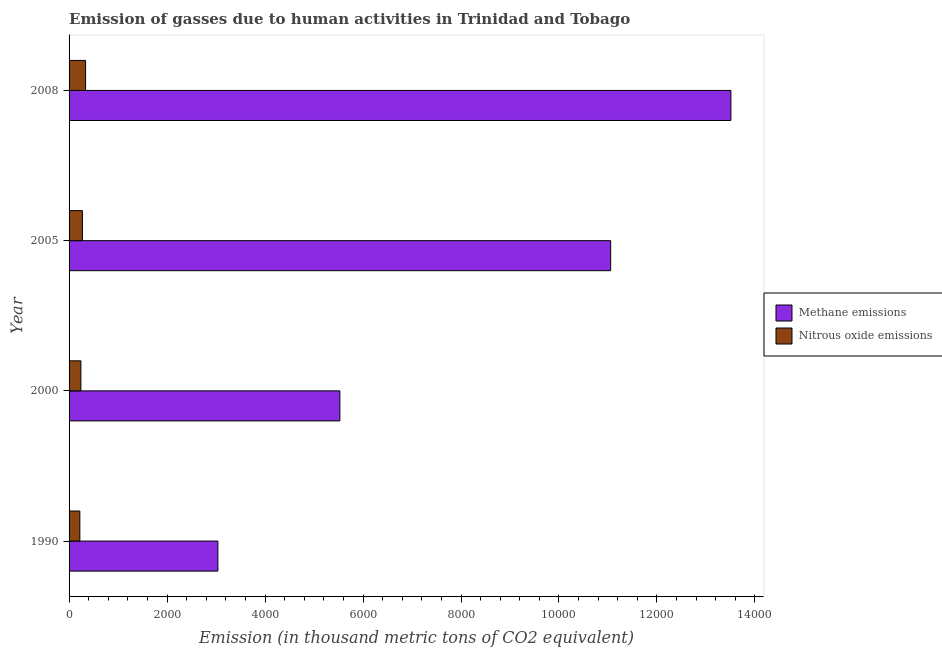How many different coloured bars are there?
Give a very brief answer. 2. Are the number of bars on each tick of the Y-axis equal?
Keep it short and to the point. Yes. How many bars are there on the 1st tick from the top?
Offer a terse response. 2. How many bars are there on the 3rd tick from the bottom?
Your answer should be very brief. 2. What is the label of the 2nd group of bars from the top?
Your response must be concise. 2005. What is the amount of nitrous oxide emissions in 2005?
Provide a short and direct response. 272.8. Across all years, what is the maximum amount of methane emissions?
Ensure brevity in your answer.  1.35e+04. Across all years, what is the minimum amount of methane emissions?
Your answer should be very brief. 3037.6. In which year was the amount of methane emissions minimum?
Your answer should be very brief. 1990. What is the total amount of nitrous oxide emissions in the graph?
Your answer should be compact. 1071. What is the difference between the amount of methane emissions in 1990 and that in 2000?
Give a very brief answer. -2489.9. What is the difference between the amount of methane emissions in 2000 and the amount of nitrous oxide emissions in 2008?
Your response must be concise. 5190.7. What is the average amount of methane emissions per year?
Your response must be concise. 8282.1. In the year 2000, what is the difference between the amount of nitrous oxide emissions and amount of methane emissions?
Offer a very short reply. -5286. What is the ratio of the amount of nitrous oxide emissions in 1990 to that in 2008?
Provide a short and direct response. 0.65. Is the amount of methane emissions in 1990 less than that in 2008?
Offer a very short reply. Yes. Is the difference between the amount of methane emissions in 2005 and 2008 greater than the difference between the amount of nitrous oxide emissions in 2005 and 2008?
Your answer should be compact. No. What is the difference between the highest and the second highest amount of methane emissions?
Offer a terse response. 2453.9. What is the difference between the highest and the lowest amount of methane emissions?
Give a very brief answer. 1.05e+04. In how many years, is the amount of nitrous oxide emissions greater than the average amount of nitrous oxide emissions taken over all years?
Your answer should be compact. 2. What does the 2nd bar from the top in 1990 represents?
Make the answer very short. Methane emissions. What does the 1st bar from the bottom in 2005 represents?
Your answer should be compact. Methane emissions. How are the legend labels stacked?
Make the answer very short. Vertical. What is the title of the graph?
Offer a terse response. Emission of gasses due to human activities in Trinidad and Tobago. Does "Transport services" appear as one of the legend labels in the graph?
Provide a short and direct response. No. What is the label or title of the X-axis?
Provide a succinct answer. Emission (in thousand metric tons of CO2 equivalent). What is the label or title of the Y-axis?
Provide a succinct answer. Year. What is the Emission (in thousand metric tons of CO2 equivalent) in Methane emissions in 1990?
Your answer should be very brief. 3037.6. What is the Emission (in thousand metric tons of CO2 equivalent) of Nitrous oxide emissions in 1990?
Your answer should be very brief. 219.9. What is the Emission (in thousand metric tons of CO2 equivalent) in Methane emissions in 2000?
Keep it short and to the point. 5527.5. What is the Emission (in thousand metric tons of CO2 equivalent) of Nitrous oxide emissions in 2000?
Ensure brevity in your answer.  241.5. What is the Emission (in thousand metric tons of CO2 equivalent) in Methane emissions in 2005?
Your answer should be compact. 1.11e+04. What is the Emission (in thousand metric tons of CO2 equivalent) of Nitrous oxide emissions in 2005?
Your response must be concise. 272.8. What is the Emission (in thousand metric tons of CO2 equivalent) in Methane emissions in 2008?
Offer a very short reply. 1.35e+04. What is the Emission (in thousand metric tons of CO2 equivalent) in Nitrous oxide emissions in 2008?
Give a very brief answer. 336.8. Across all years, what is the maximum Emission (in thousand metric tons of CO2 equivalent) of Methane emissions?
Offer a very short reply. 1.35e+04. Across all years, what is the maximum Emission (in thousand metric tons of CO2 equivalent) in Nitrous oxide emissions?
Your answer should be compact. 336.8. Across all years, what is the minimum Emission (in thousand metric tons of CO2 equivalent) in Methane emissions?
Make the answer very short. 3037.6. Across all years, what is the minimum Emission (in thousand metric tons of CO2 equivalent) of Nitrous oxide emissions?
Provide a short and direct response. 219.9. What is the total Emission (in thousand metric tons of CO2 equivalent) in Methane emissions in the graph?
Keep it short and to the point. 3.31e+04. What is the total Emission (in thousand metric tons of CO2 equivalent) of Nitrous oxide emissions in the graph?
Give a very brief answer. 1071. What is the difference between the Emission (in thousand metric tons of CO2 equivalent) in Methane emissions in 1990 and that in 2000?
Ensure brevity in your answer.  -2489.9. What is the difference between the Emission (in thousand metric tons of CO2 equivalent) in Nitrous oxide emissions in 1990 and that in 2000?
Provide a succinct answer. -21.6. What is the difference between the Emission (in thousand metric tons of CO2 equivalent) of Methane emissions in 1990 and that in 2005?
Provide a succinct answer. -8017.1. What is the difference between the Emission (in thousand metric tons of CO2 equivalent) in Nitrous oxide emissions in 1990 and that in 2005?
Offer a terse response. -52.9. What is the difference between the Emission (in thousand metric tons of CO2 equivalent) of Methane emissions in 1990 and that in 2008?
Your response must be concise. -1.05e+04. What is the difference between the Emission (in thousand metric tons of CO2 equivalent) of Nitrous oxide emissions in 1990 and that in 2008?
Your answer should be compact. -116.9. What is the difference between the Emission (in thousand metric tons of CO2 equivalent) in Methane emissions in 2000 and that in 2005?
Your answer should be very brief. -5527.2. What is the difference between the Emission (in thousand metric tons of CO2 equivalent) in Nitrous oxide emissions in 2000 and that in 2005?
Your answer should be compact. -31.3. What is the difference between the Emission (in thousand metric tons of CO2 equivalent) of Methane emissions in 2000 and that in 2008?
Your answer should be compact. -7981.1. What is the difference between the Emission (in thousand metric tons of CO2 equivalent) in Nitrous oxide emissions in 2000 and that in 2008?
Offer a terse response. -95.3. What is the difference between the Emission (in thousand metric tons of CO2 equivalent) in Methane emissions in 2005 and that in 2008?
Give a very brief answer. -2453.9. What is the difference between the Emission (in thousand metric tons of CO2 equivalent) in Nitrous oxide emissions in 2005 and that in 2008?
Provide a short and direct response. -64. What is the difference between the Emission (in thousand metric tons of CO2 equivalent) in Methane emissions in 1990 and the Emission (in thousand metric tons of CO2 equivalent) in Nitrous oxide emissions in 2000?
Offer a very short reply. 2796.1. What is the difference between the Emission (in thousand metric tons of CO2 equivalent) of Methane emissions in 1990 and the Emission (in thousand metric tons of CO2 equivalent) of Nitrous oxide emissions in 2005?
Your answer should be very brief. 2764.8. What is the difference between the Emission (in thousand metric tons of CO2 equivalent) in Methane emissions in 1990 and the Emission (in thousand metric tons of CO2 equivalent) in Nitrous oxide emissions in 2008?
Your answer should be compact. 2700.8. What is the difference between the Emission (in thousand metric tons of CO2 equivalent) in Methane emissions in 2000 and the Emission (in thousand metric tons of CO2 equivalent) in Nitrous oxide emissions in 2005?
Offer a terse response. 5254.7. What is the difference between the Emission (in thousand metric tons of CO2 equivalent) of Methane emissions in 2000 and the Emission (in thousand metric tons of CO2 equivalent) of Nitrous oxide emissions in 2008?
Your answer should be compact. 5190.7. What is the difference between the Emission (in thousand metric tons of CO2 equivalent) of Methane emissions in 2005 and the Emission (in thousand metric tons of CO2 equivalent) of Nitrous oxide emissions in 2008?
Give a very brief answer. 1.07e+04. What is the average Emission (in thousand metric tons of CO2 equivalent) of Methane emissions per year?
Your answer should be very brief. 8282.1. What is the average Emission (in thousand metric tons of CO2 equivalent) in Nitrous oxide emissions per year?
Ensure brevity in your answer.  267.75. In the year 1990, what is the difference between the Emission (in thousand metric tons of CO2 equivalent) of Methane emissions and Emission (in thousand metric tons of CO2 equivalent) of Nitrous oxide emissions?
Keep it short and to the point. 2817.7. In the year 2000, what is the difference between the Emission (in thousand metric tons of CO2 equivalent) of Methane emissions and Emission (in thousand metric tons of CO2 equivalent) of Nitrous oxide emissions?
Make the answer very short. 5286. In the year 2005, what is the difference between the Emission (in thousand metric tons of CO2 equivalent) in Methane emissions and Emission (in thousand metric tons of CO2 equivalent) in Nitrous oxide emissions?
Your response must be concise. 1.08e+04. In the year 2008, what is the difference between the Emission (in thousand metric tons of CO2 equivalent) in Methane emissions and Emission (in thousand metric tons of CO2 equivalent) in Nitrous oxide emissions?
Provide a succinct answer. 1.32e+04. What is the ratio of the Emission (in thousand metric tons of CO2 equivalent) of Methane emissions in 1990 to that in 2000?
Give a very brief answer. 0.55. What is the ratio of the Emission (in thousand metric tons of CO2 equivalent) in Nitrous oxide emissions in 1990 to that in 2000?
Provide a short and direct response. 0.91. What is the ratio of the Emission (in thousand metric tons of CO2 equivalent) of Methane emissions in 1990 to that in 2005?
Provide a short and direct response. 0.27. What is the ratio of the Emission (in thousand metric tons of CO2 equivalent) of Nitrous oxide emissions in 1990 to that in 2005?
Offer a terse response. 0.81. What is the ratio of the Emission (in thousand metric tons of CO2 equivalent) in Methane emissions in 1990 to that in 2008?
Provide a succinct answer. 0.22. What is the ratio of the Emission (in thousand metric tons of CO2 equivalent) of Nitrous oxide emissions in 1990 to that in 2008?
Offer a terse response. 0.65. What is the ratio of the Emission (in thousand metric tons of CO2 equivalent) of Nitrous oxide emissions in 2000 to that in 2005?
Make the answer very short. 0.89. What is the ratio of the Emission (in thousand metric tons of CO2 equivalent) of Methane emissions in 2000 to that in 2008?
Provide a succinct answer. 0.41. What is the ratio of the Emission (in thousand metric tons of CO2 equivalent) of Nitrous oxide emissions in 2000 to that in 2008?
Offer a very short reply. 0.72. What is the ratio of the Emission (in thousand metric tons of CO2 equivalent) in Methane emissions in 2005 to that in 2008?
Your response must be concise. 0.82. What is the ratio of the Emission (in thousand metric tons of CO2 equivalent) in Nitrous oxide emissions in 2005 to that in 2008?
Make the answer very short. 0.81. What is the difference between the highest and the second highest Emission (in thousand metric tons of CO2 equivalent) of Methane emissions?
Give a very brief answer. 2453.9. What is the difference between the highest and the lowest Emission (in thousand metric tons of CO2 equivalent) of Methane emissions?
Your response must be concise. 1.05e+04. What is the difference between the highest and the lowest Emission (in thousand metric tons of CO2 equivalent) of Nitrous oxide emissions?
Provide a short and direct response. 116.9. 